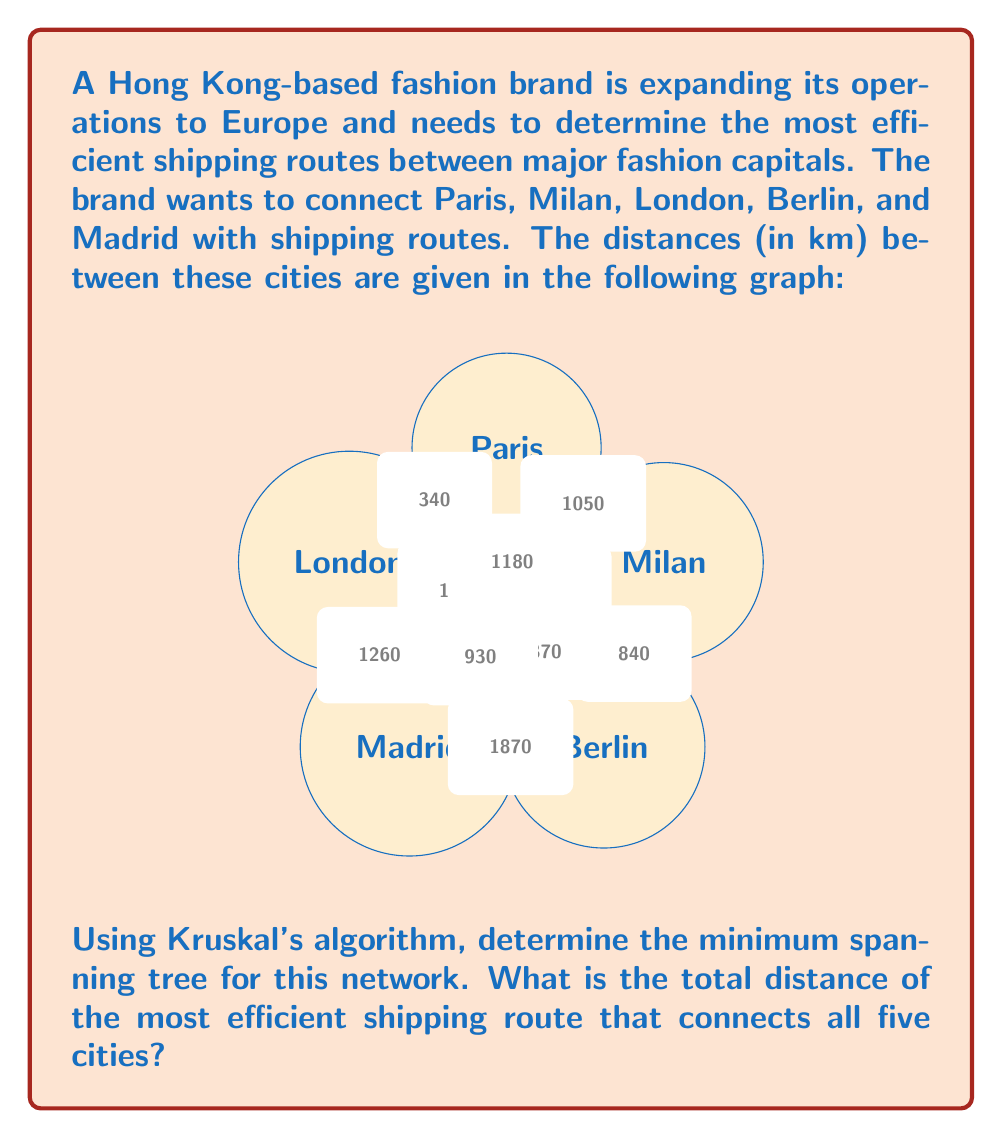Provide a solution to this math problem. Let's solve this step-by-step using Kruskal's algorithm:

1) First, we list all edges in order of increasing weight:
   Paris - London: 340 km
   Paris - Berlin: 880 km
   Milan - Berlin: 840 km
   London - Berlin: 930 km
   Paris - Milan: 1050 km
   Milan - London: 1180 km
   London - Madrid: 1260 km
   Paris - Madrid: 1270 km
   Milan - Madrid: 1370 km
   Berlin - Madrid: 1870 km

2) Now, we start adding edges to our minimum spanning tree, starting with the shortest, as long as they don't create a cycle:

   a) Paris - London (340 km): Add
   b) Milan - Berlin (840 km): Add
   c) Paris - Berlin (880 km): Skip (would create a cycle)
   d) London - Berlin (930 km): Skip (would create a cycle)
   e) Paris - Milan (1050 km): Add
   f) Milan - London (1180 km): Skip (would create a cycle)
   g) London - Madrid (1260 km): Add

3) At this point, we have connected all five cities without creating any cycles, so we stop.

4) The edges in our minimum spanning tree are:
   Paris - London (340 km)
   Milan - Berlin (840 km)
   Paris - Milan (1050 km)
   London - Madrid (1260 km)

5) To get the total distance, we sum these up:

   $$340 + 840 + 1050 + 1260 = 3490 \text{ km}$$

Therefore, the most efficient shipping route that connects all five cities has a total distance of 3490 km.
Answer: 3490 km 